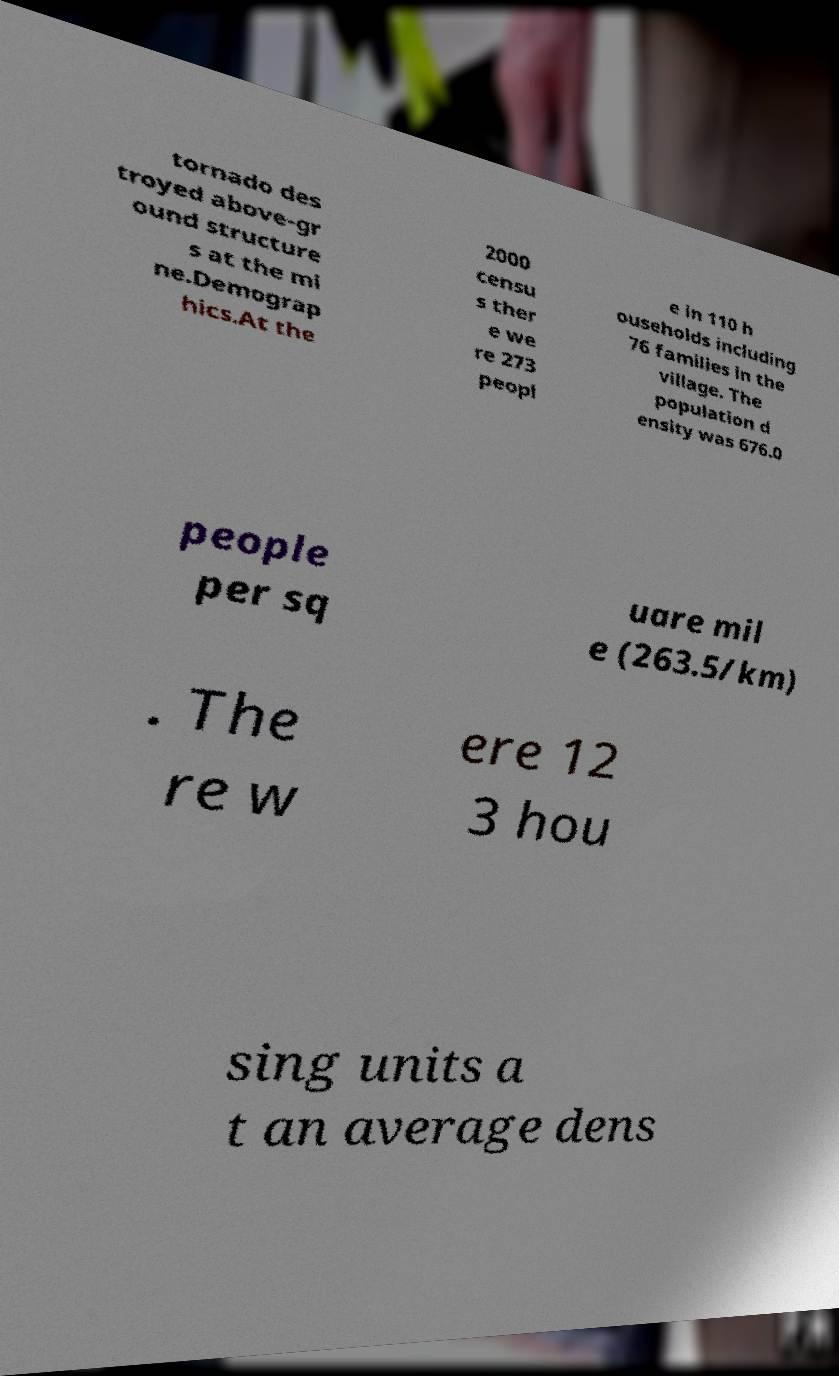For documentation purposes, I need the text within this image transcribed. Could you provide that? tornado des troyed above-gr ound structure s at the mi ne.Demograp hics.At the 2000 censu s ther e we re 273 peopl e in 110 h ouseholds including 76 families in the village. The population d ensity was 676.0 people per sq uare mil e (263.5/km) . The re w ere 12 3 hou sing units a t an average dens 